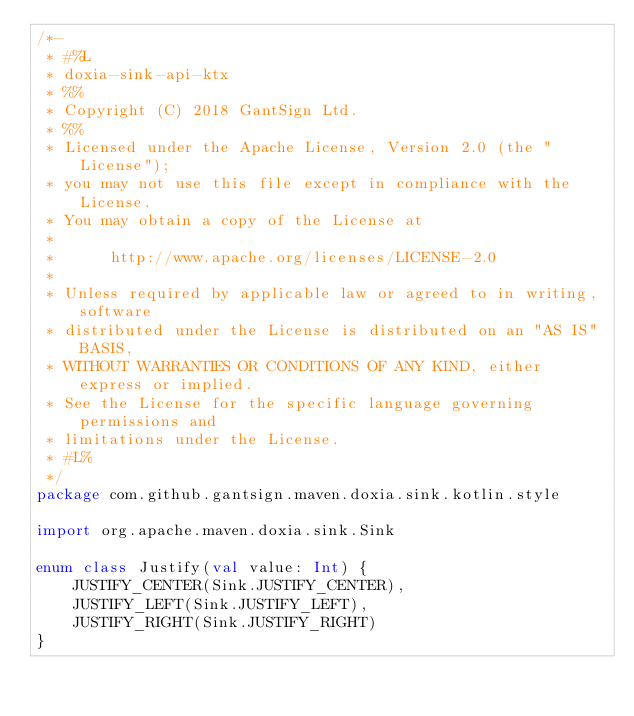<code> <loc_0><loc_0><loc_500><loc_500><_Kotlin_>/*-
 * #%L
 * doxia-sink-api-ktx
 * %%
 * Copyright (C) 2018 GantSign Ltd.
 * %%
 * Licensed under the Apache License, Version 2.0 (the "License");
 * you may not use this file except in compliance with the License.
 * You may obtain a copy of the License at
 *
 *      http://www.apache.org/licenses/LICENSE-2.0
 *
 * Unless required by applicable law or agreed to in writing, software
 * distributed under the License is distributed on an "AS IS" BASIS,
 * WITHOUT WARRANTIES OR CONDITIONS OF ANY KIND, either express or implied.
 * See the License for the specific language governing permissions and
 * limitations under the License.
 * #L%
 */
package com.github.gantsign.maven.doxia.sink.kotlin.style

import org.apache.maven.doxia.sink.Sink

enum class Justify(val value: Int) {
    JUSTIFY_CENTER(Sink.JUSTIFY_CENTER),
    JUSTIFY_LEFT(Sink.JUSTIFY_LEFT),
    JUSTIFY_RIGHT(Sink.JUSTIFY_RIGHT)
}
</code> 